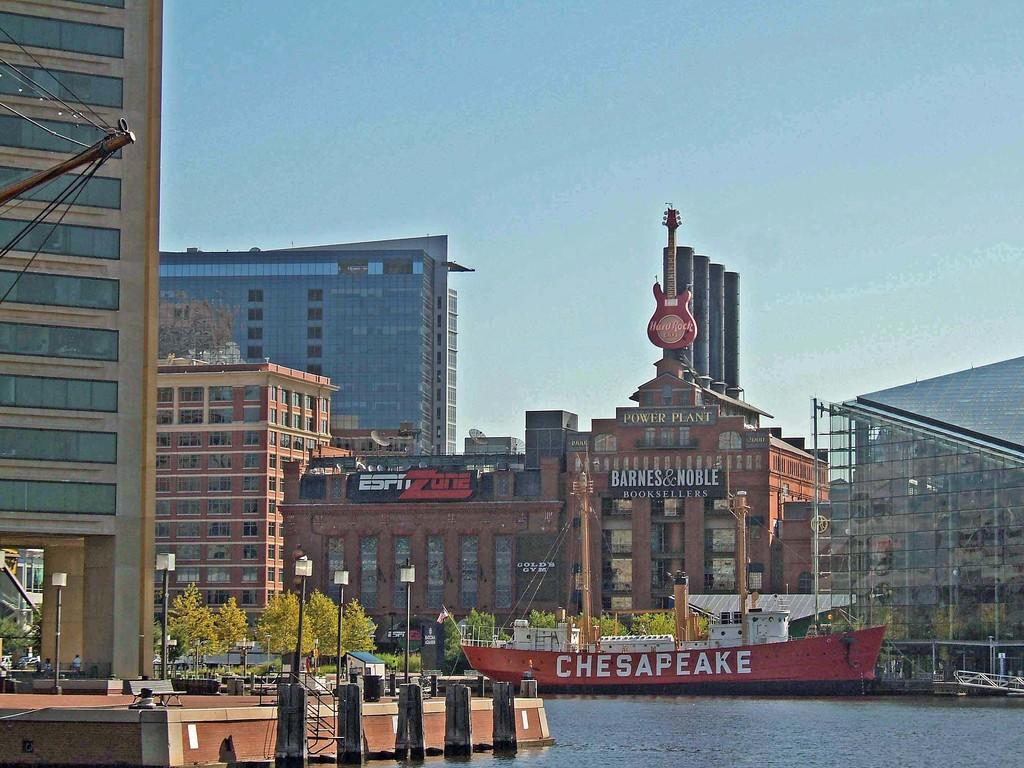What color is the sky in the image? The sky is blue in the image. What is above the water in the image? There is a ship above the water in the image. What can be seen in the background of the image? There are buildings and glass windows in the background of the image. What type of structures are present in the image? There are light poles in the image. What type of vegetation is present in the image? There are trees in the image. What type of advertisement can be seen in the image? There is an advertisement of a guitar in the image. Where is the grandmother sitting in the image? There is no grandmother present in the image. What type of powder is being used by the people in the image? There is no powder or any indication of its use in the image. 